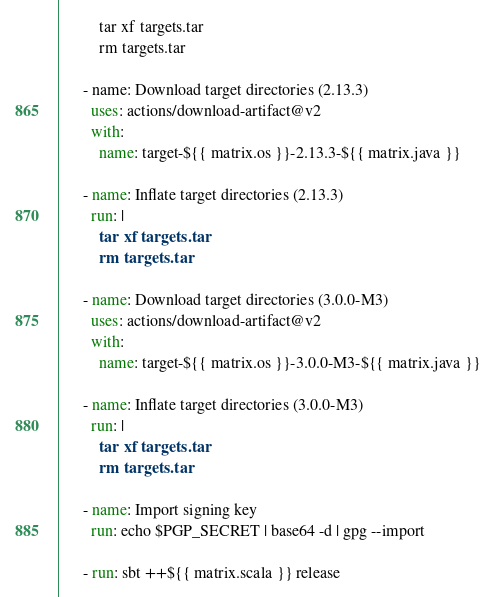<code> <loc_0><loc_0><loc_500><loc_500><_YAML_>          tar xf targets.tar
          rm targets.tar

      - name: Download target directories (2.13.3)
        uses: actions/download-artifact@v2
        with:
          name: target-${{ matrix.os }}-2.13.3-${{ matrix.java }}

      - name: Inflate target directories (2.13.3)
        run: |
          tar xf targets.tar
          rm targets.tar

      - name: Download target directories (3.0.0-M3)
        uses: actions/download-artifact@v2
        with:
          name: target-${{ matrix.os }}-3.0.0-M3-${{ matrix.java }}

      - name: Inflate target directories (3.0.0-M3)
        run: |
          tar xf targets.tar
          rm targets.tar

      - name: Import signing key
        run: echo $PGP_SECRET | base64 -d | gpg --import

      - run: sbt ++${{ matrix.scala }} release</code> 